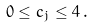<formula> <loc_0><loc_0><loc_500><loc_500>0 \leq c _ { j } \leq 4 \, .</formula> 